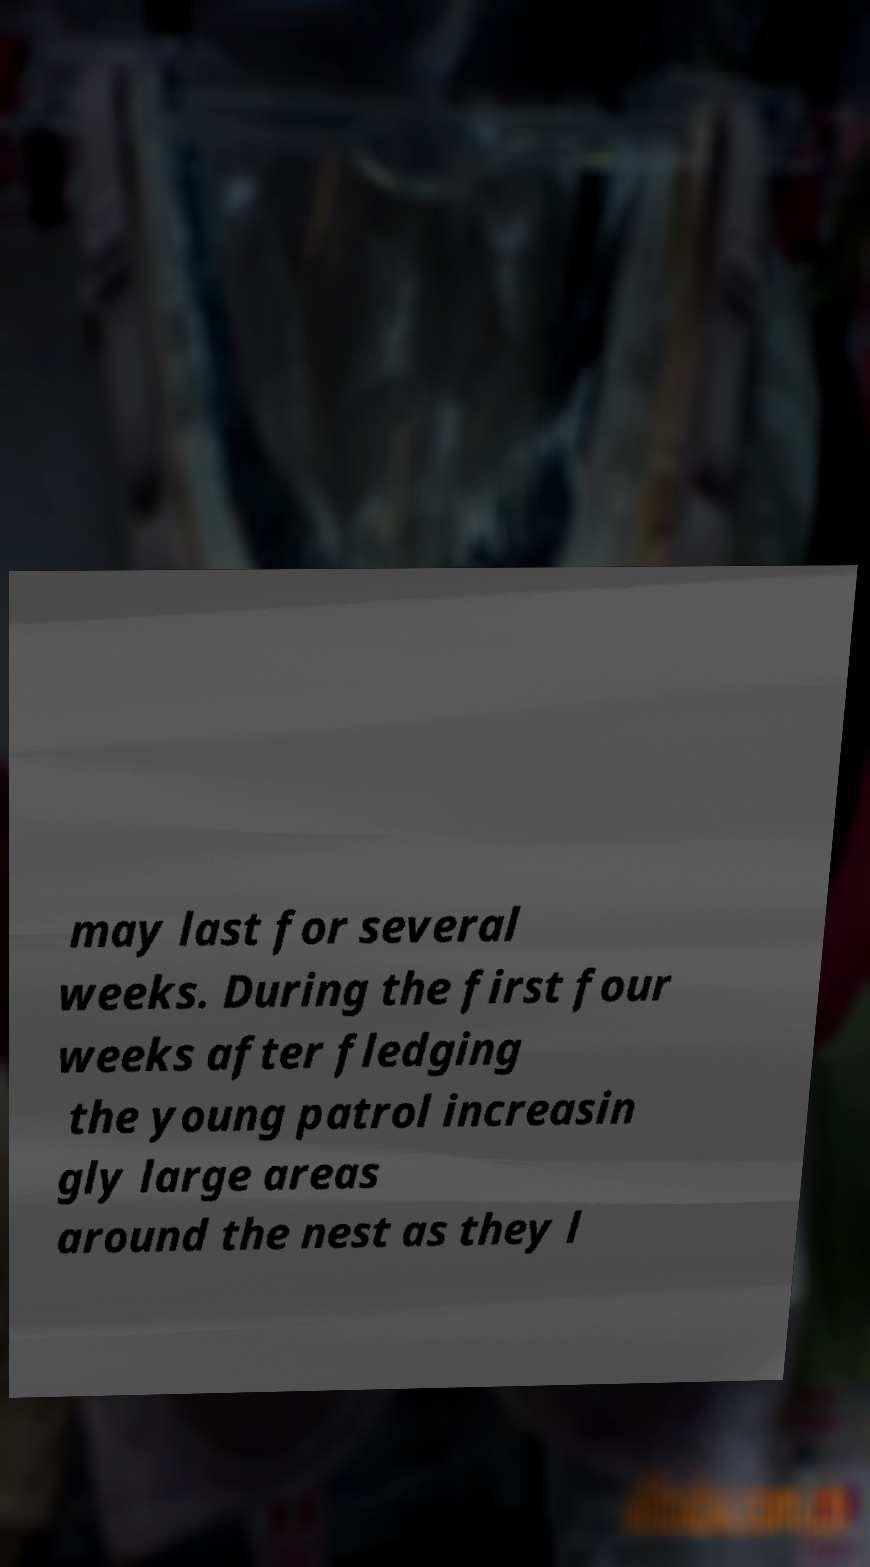Can you accurately transcribe the text from the provided image for me? may last for several weeks. During the first four weeks after fledging the young patrol increasin gly large areas around the nest as they l 